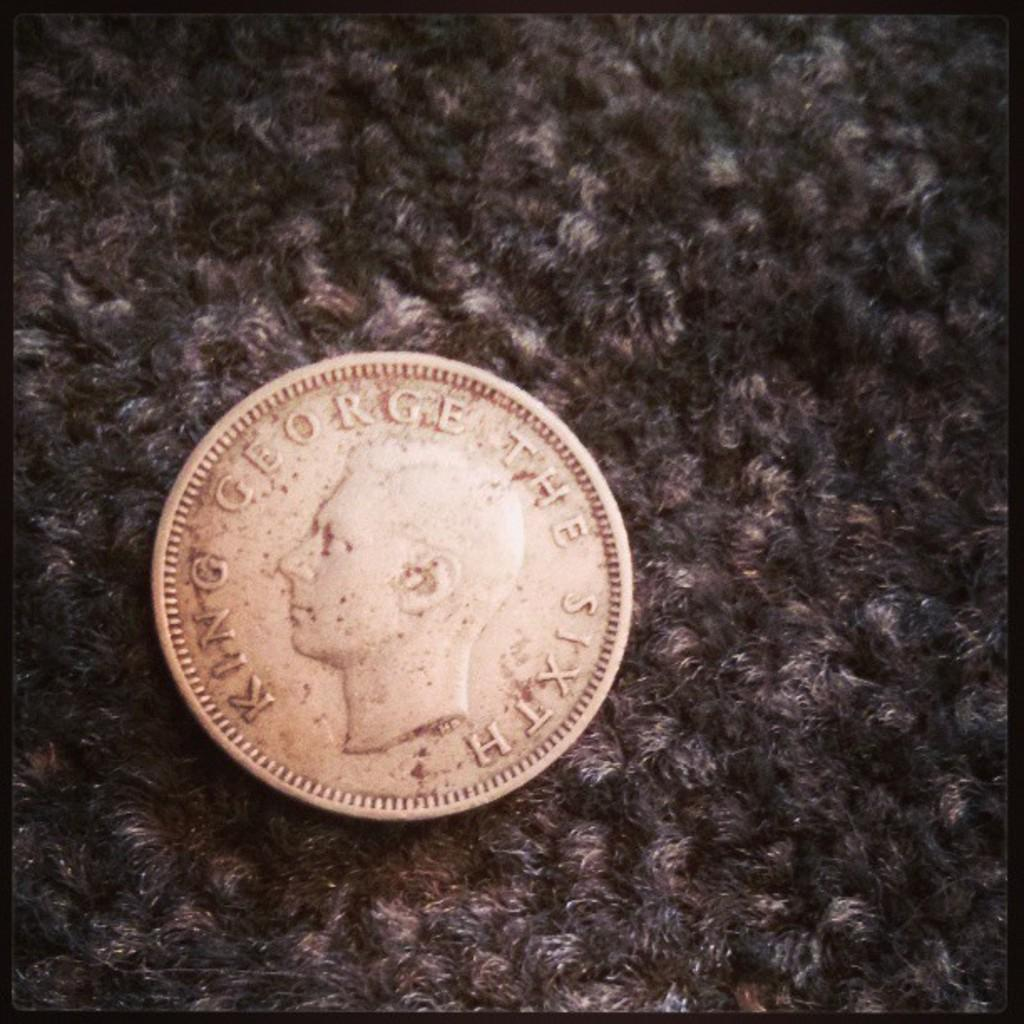<image>
Relay a brief, clear account of the picture shown. A silver coin on a carpeted background with King George The Sixth on its surface. 